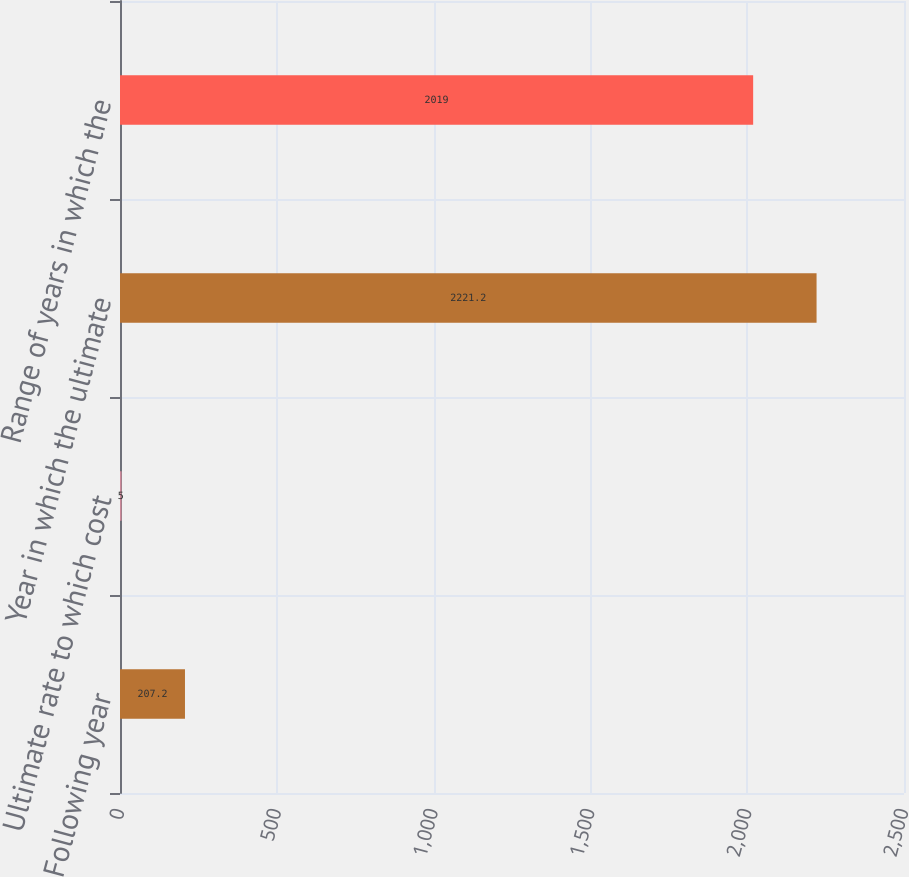Convert chart to OTSL. <chart><loc_0><loc_0><loc_500><loc_500><bar_chart><fcel>Following year<fcel>Ultimate rate to which cost<fcel>Year in which the ultimate<fcel>Range of years in which the<nl><fcel>207.2<fcel>5<fcel>2221.2<fcel>2019<nl></chart> 